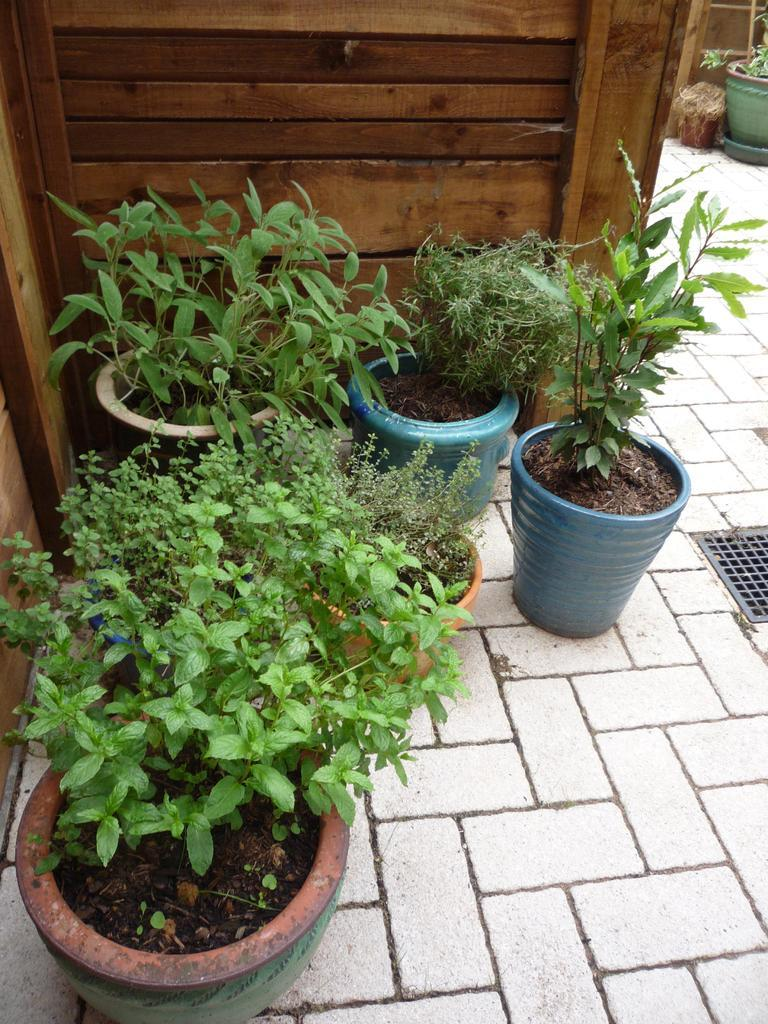What can be found in the flower pots in the image? There are plants in the flower pots in the image. What type of material is the fence made of in the image? There is a wooden fence in the image. What type of linen is used to cover the plants in the image? There is no linen present in the image; the plants are in flower pots without any covering. 